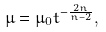Convert formula to latex. <formula><loc_0><loc_0><loc_500><loc_500>\mu = \mu _ { 0 } t ^ { - \frac { 2 n } { n - 2 } } ,</formula> 